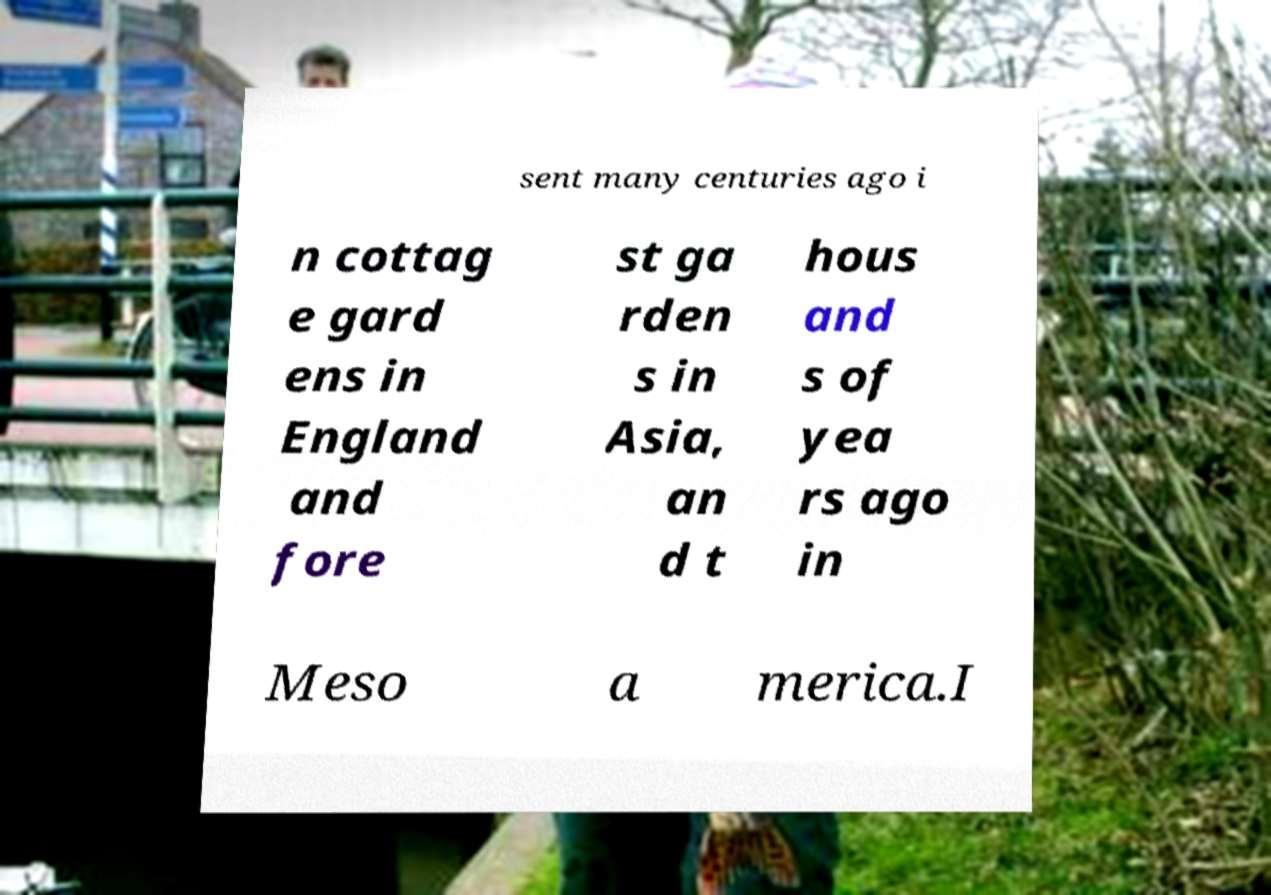Please identify and transcribe the text found in this image. sent many centuries ago i n cottag e gard ens in England and fore st ga rden s in Asia, an d t hous and s of yea rs ago in Meso a merica.I 